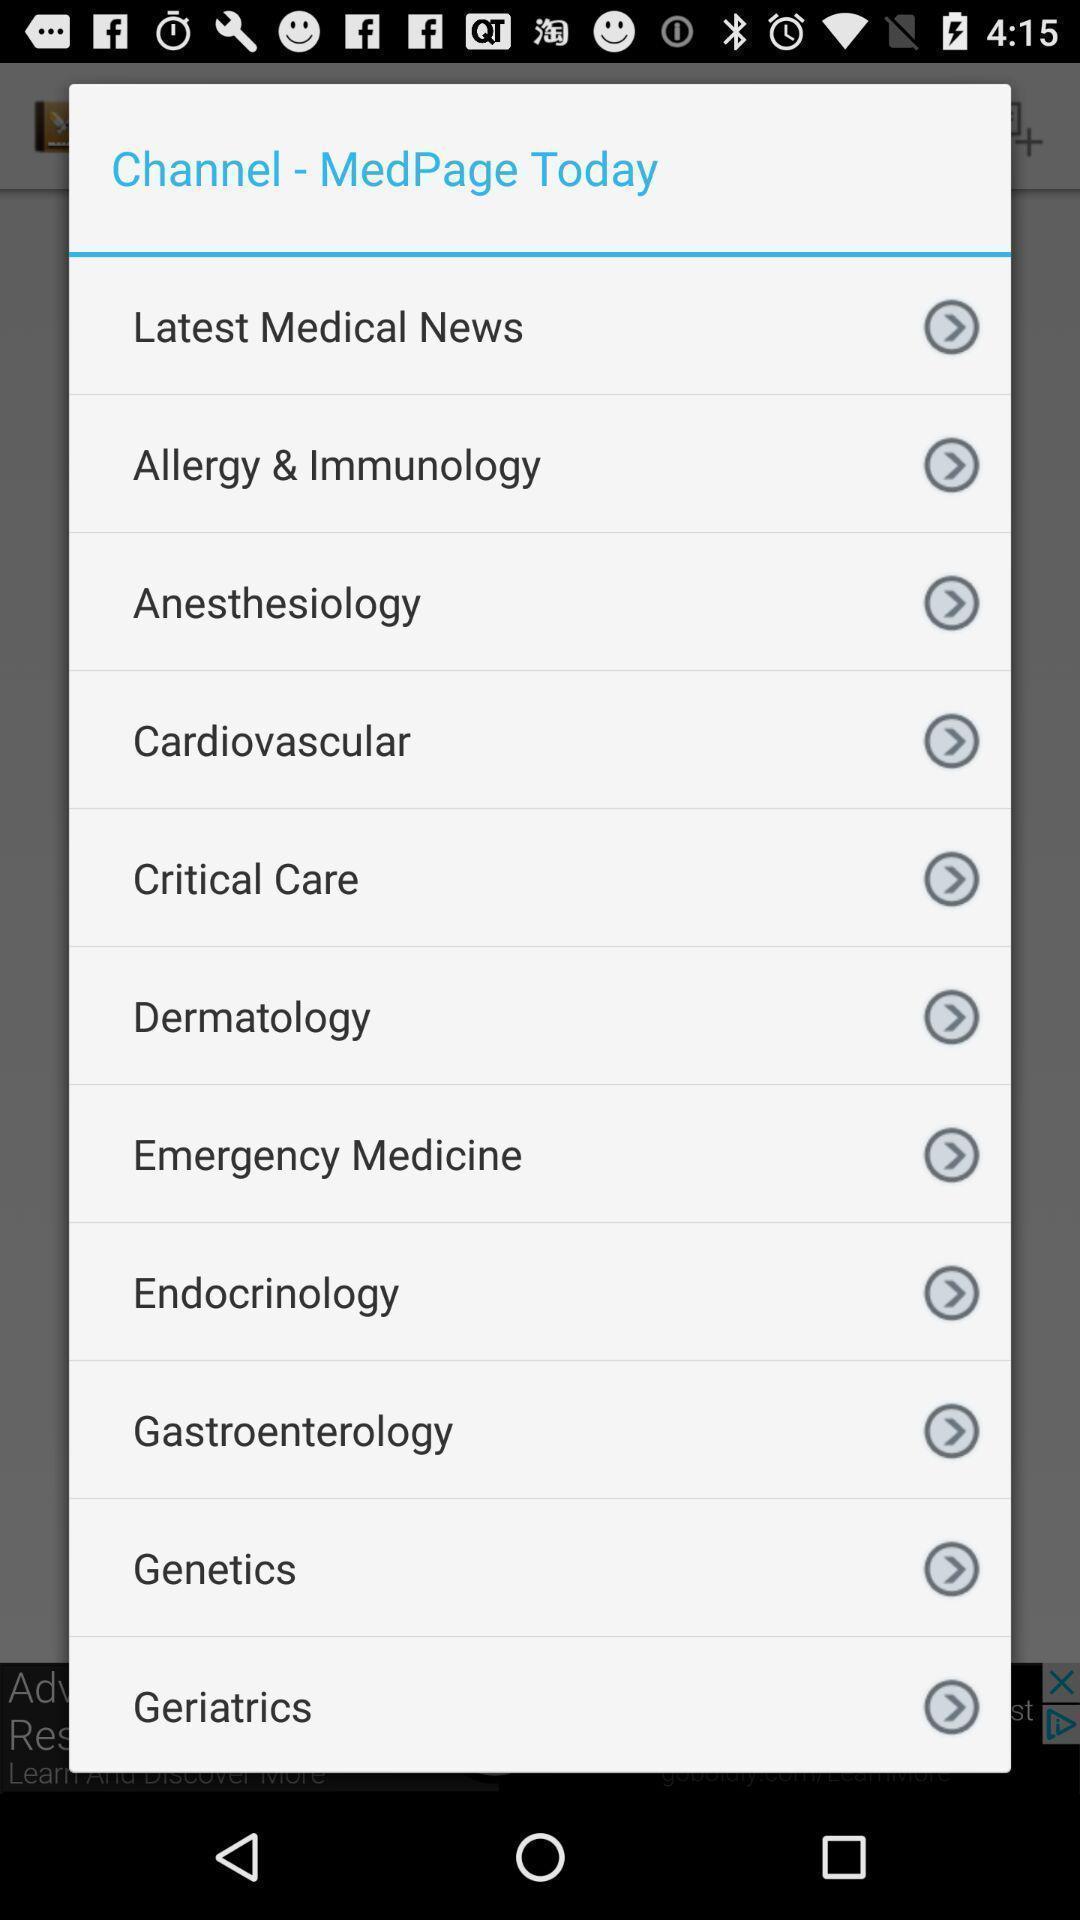Describe this image in words. Pop-up displaying list of topics. 